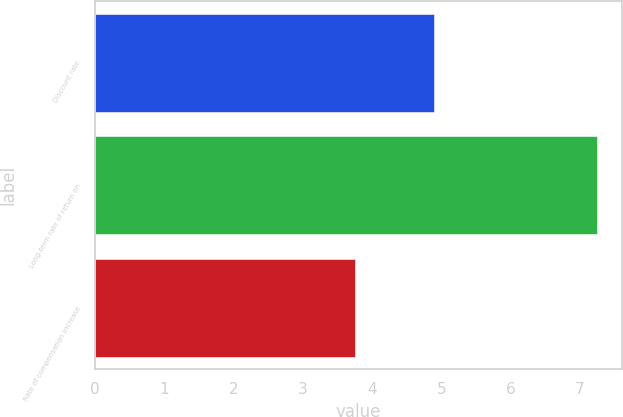Convert chart. <chart><loc_0><loc_0><loc_500><loc_500><bar_chart><fcel>Discount rate<fcel>Long-term rate of return on<fcel>Rate of compensation increase<nl><fcel>4.9<fcel>7.25<fcel>3.75<nl></chart> 